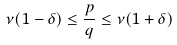<formula> <loc_0><loc_0><loc_500><loc_500>\nu ( 1 - \delta ) \leq \frac { p } { q } \leq \nu ( 1 + \delta )</formula> 